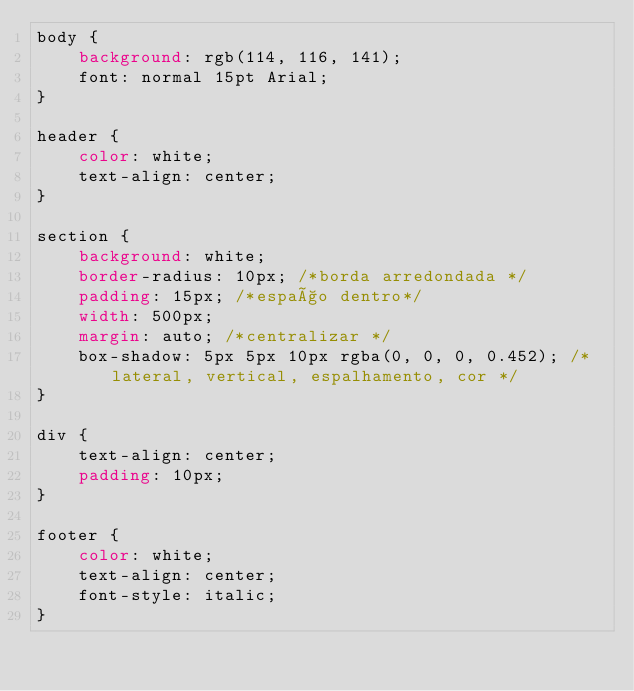<code> <loc_0><loc_0><loc_500><loc_500><_CSS_>body {
    background: rgb(114, 116, 141);
    font: normal 15pt Arial;
}

header {
    color: white;
    text-align: center;
}

section {
    background: white;
    border-radius: 10px; /*borda arredondada */
    padding: 15px; /*espaço dentro*/
    width: 500px;
    margin: auto; /*centralizar */
    box-shadow: 5px 5px 10px rgba(0, 0, 0, 0.452); /*lateral, vertical, espalhamento, cor */
}

div {
    text-align: center;
    padding: 10px;
}

footer {
    color: white;
    text-align: center;
    font-style: italic;
}</code> 